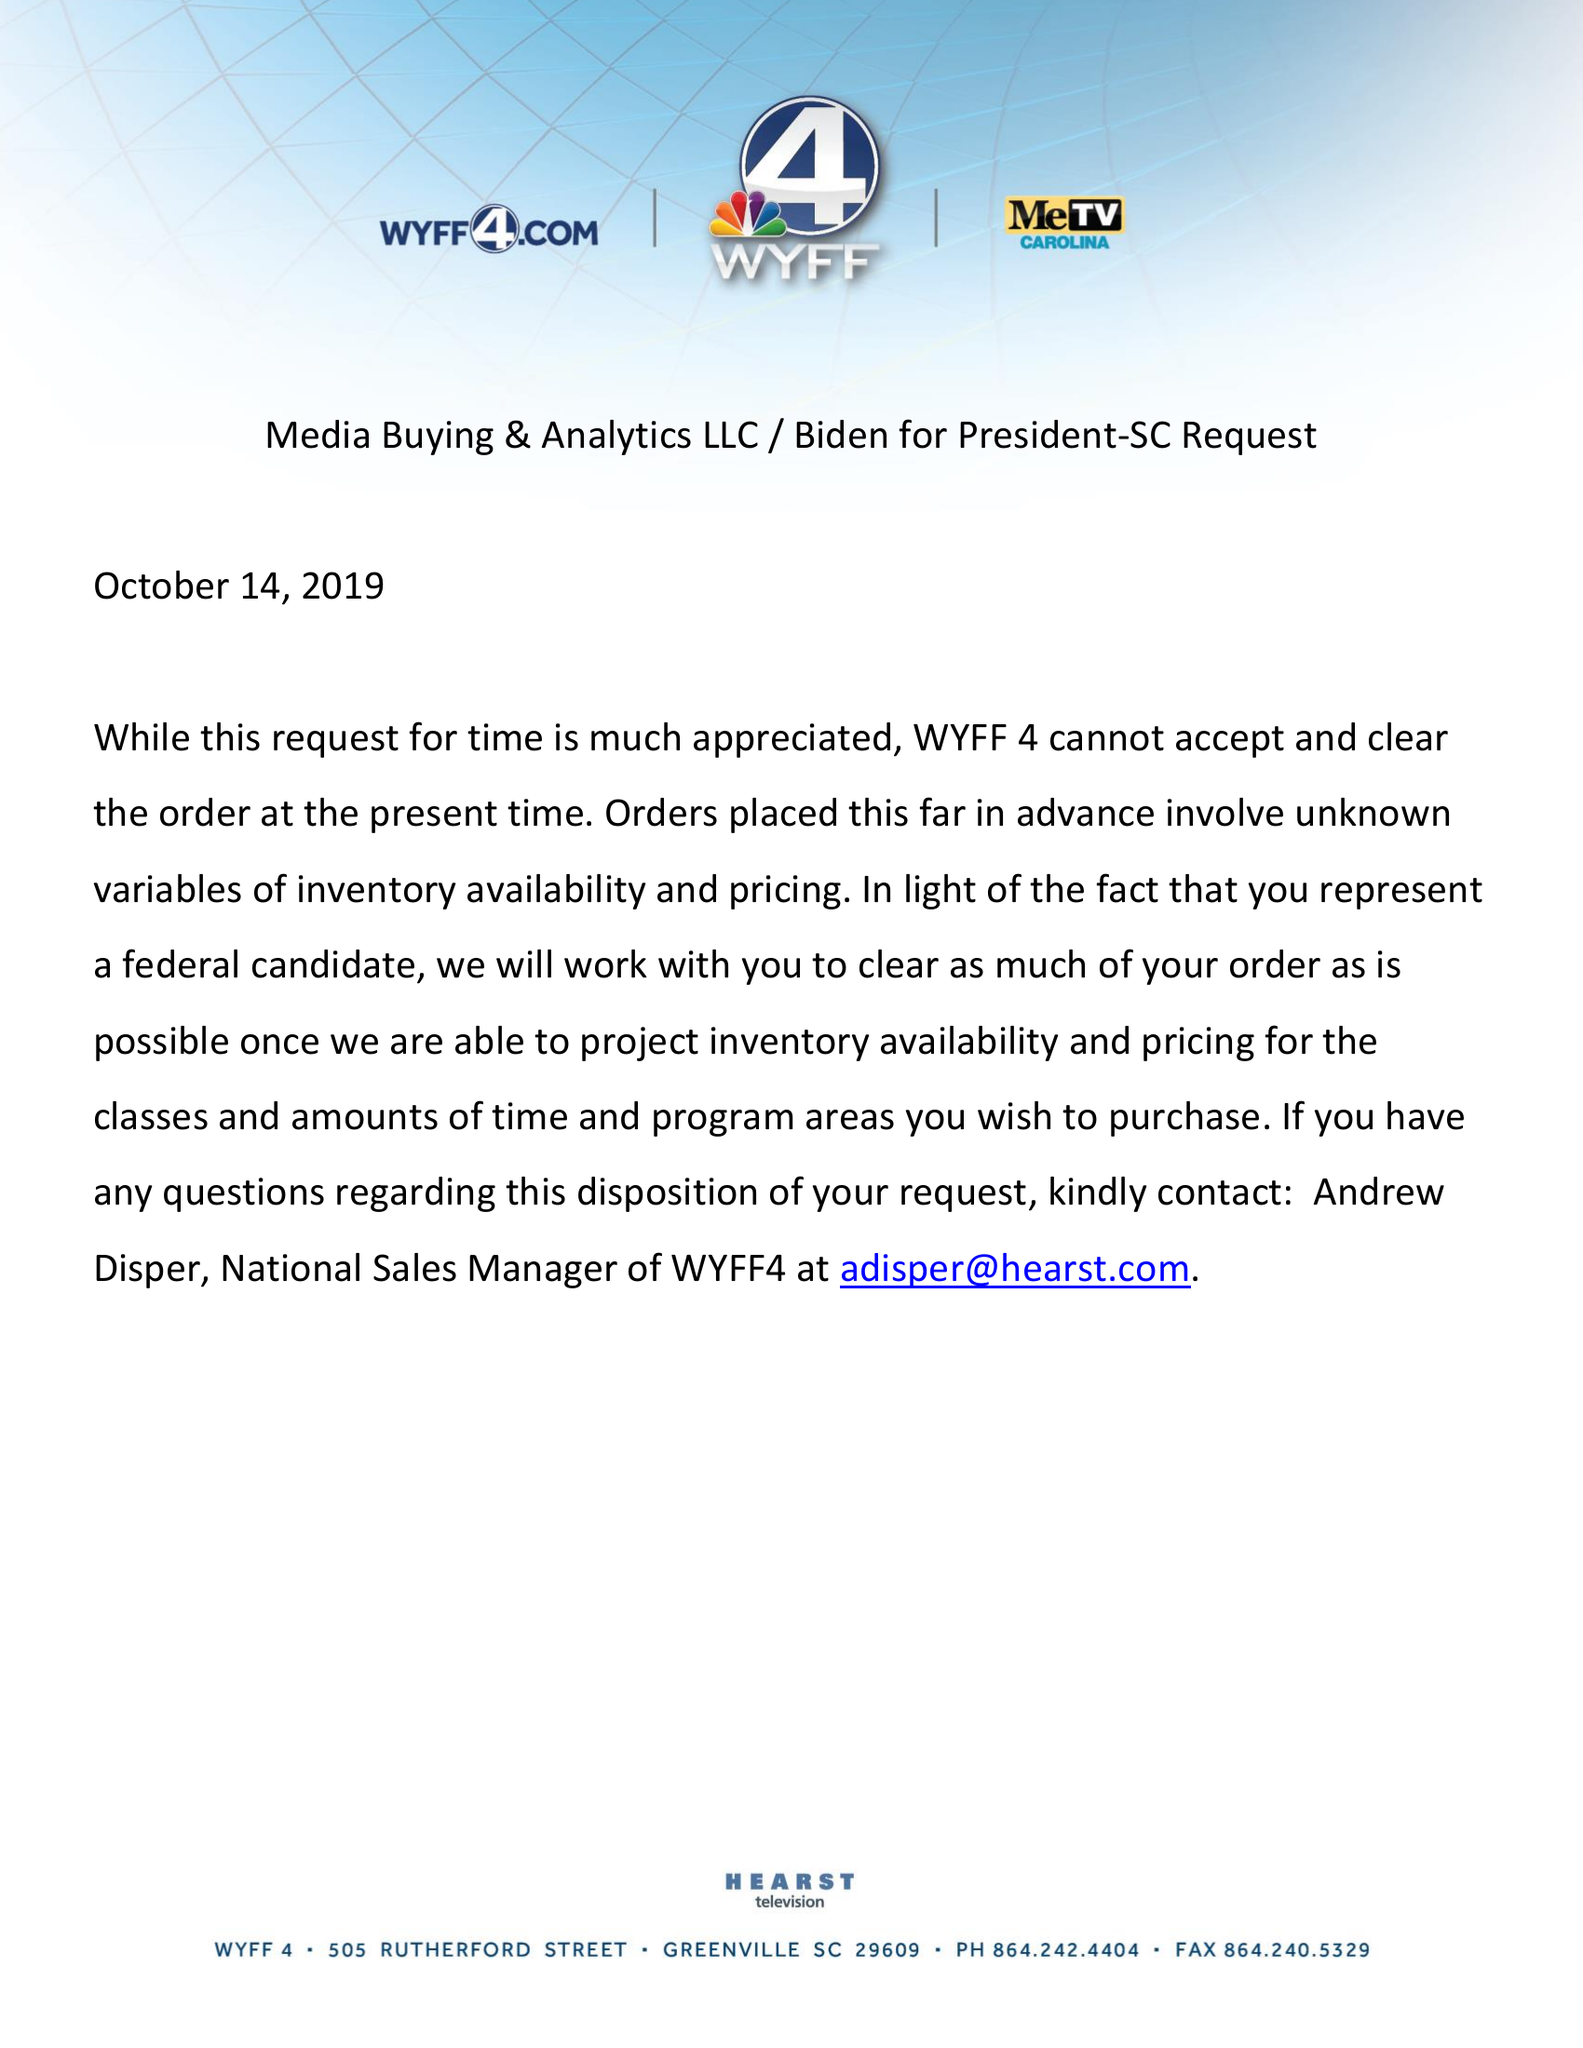What is the value for the contract_num?
Answer the question using a single word or phrase. None 